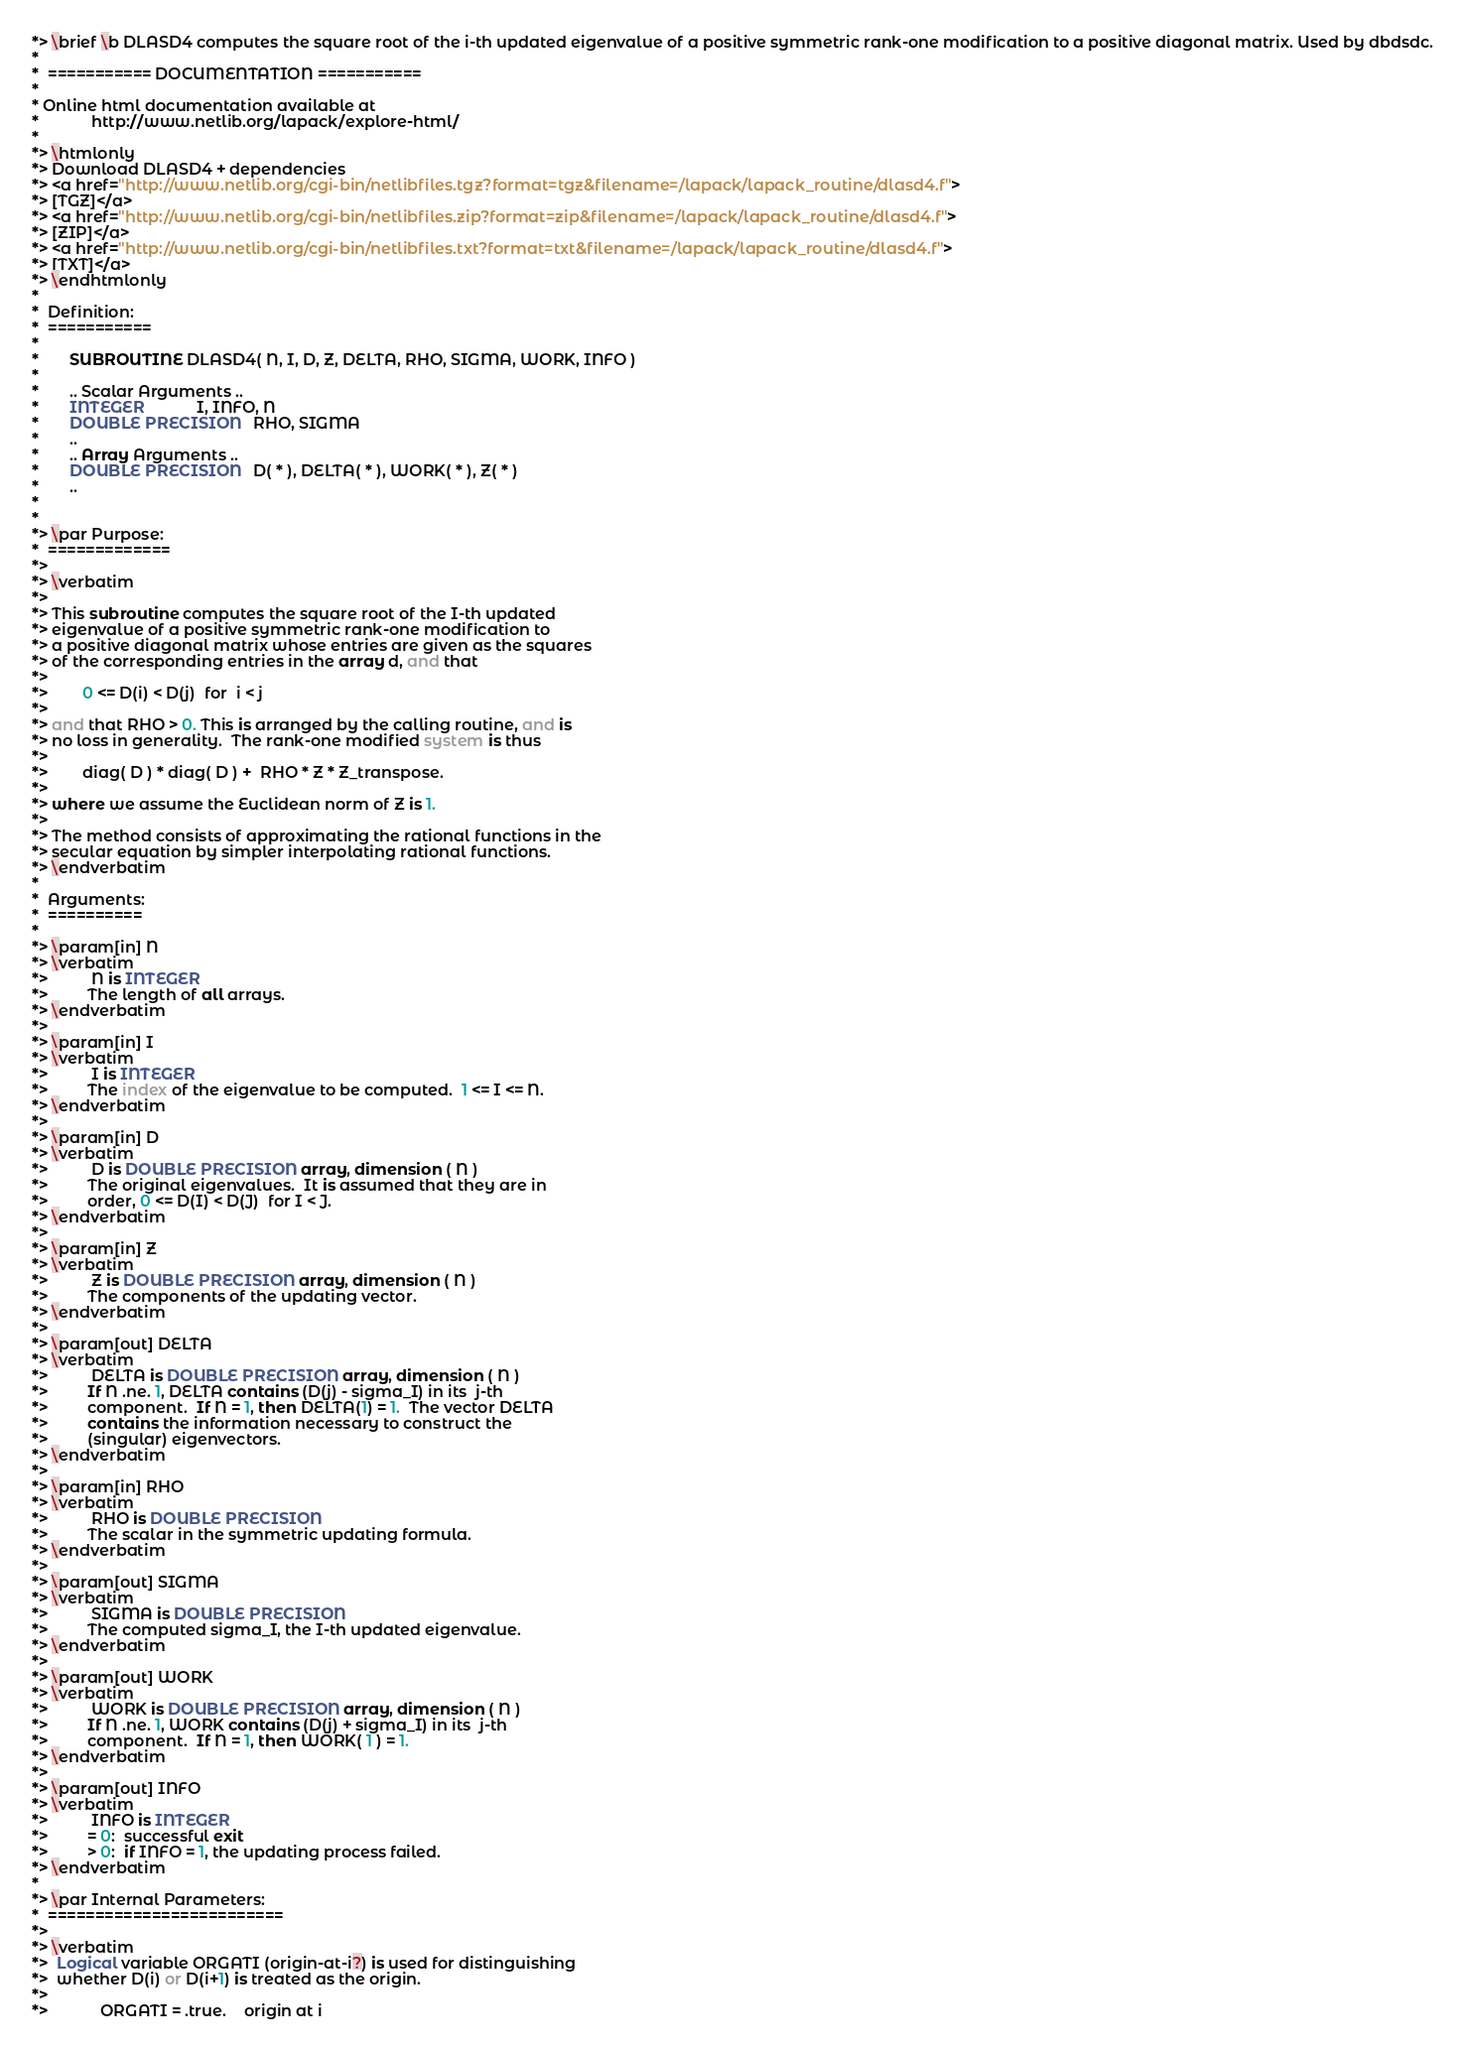Convert code to text. <code><loc_0><loc_0><loc_500><loc_500><_FORTRAN_>*> \brief \b DLASD4 computes the square root of the i-th updated eigenvalue of a positive symmetric rank-one modification to a positive diagonal matrix. Used by dbdsdc.
*
*  =========== DOCUMENTATION ===========
*
* Online html documentation available at
*            http://www.netlib.org/lapack/explore-html/
*
*> \htmlonly
*> Download DLASD4 + dependencies
*> <a href="http://www.netlib.org/cgi-bin/netlibfiles.tgz?format=tgz&filename=/lapack/lapack_routine/dlasd4.f">
*> [TGZ]</a>
*> <a href="http://www.netlib.org/cgi-bin/netlibfiles.zip?format=zip&filename=/lapack/lapack_routine/dlasd4.f">
*> [ZIP]</a>
*> <a href="http://www.netlib.org/cgi-bin/netlibfiles.txt?format=txt&filename=/lapack/lapack_routine/dlasd4.f">
*> [TXT]</a>
*> \endhtmlonly
*
*  Definition:
*  ===========
*
*       SUBROUTINE DLASD4( N, I, D, Z, DELTA, RHO, SIGMA, WORK, INFO )
*
*       .. Scalar Arguments ..
*       INTEGER            I, INFO, N
*       DOUBLE PRECISION   RHO, SIGMA
*       ..
*       .. Array Arguments ..
*       DOUBLE PRECISION   D( * ), DELTA( * ), WORK( * ), Z( * )
*       ..
*
*
*> \par Purpose:
*  =============
*>
*> \verbatim
*>
*> This subroutine computes the square root of the I-th updated
*> eigenvalue of a positive symmetric rank-one modification to
*> a positive diagonal matrix whose entries are given as the squares
*> of the corresponding entries in the array d, and that
*>
*>        0 <= D(i) < D(j)  for  i < j
*>
*> and that RHO > 0. This is arranged by the calling routine, and is
*> no loss in generality.  The rank-one modified system is thus
*>
*>        diag( D ) * diag( D ) +  RHO * Z * Z_transpose.
*>
*> where we assume the Euclidean norm of Z is 1.
*>
*> The method consists of approximating the rational functions in the
*> secular equation by simpler interpolating rational functions.
*> \endverbatim
*
*  Arguments:
*  ==========
*
*> \param[in] N
*> \verbatim
*>          N is INTEGER
*>         The length of all arrays.
*> \endverbatim
*>
*> \param[in] I
*> \verbatim
*>          I is INTEGER
*>         The index of the eigenvalue to be computed.  1 <= I <= N.
*> \endverbatim
*>
*> \param[in] D
*> \verbatim
*>          D is DOUBLE PRECISION array, dimension ( N )
*>         The original eigenvalues.  It is assumed that they are in
*>         order, 0 <= D(I) < D(J)  for I < J.
*> \endverbatim
*>
*> \param[in] Z
*> \verbatim
*>          Z is DOUBLE PRECISION array, dimension ( N )
*>         The components of the updating vector.
*> \endverbatim
*>
*> \param[out] DELTA
*> \verbatim
*>          DELTA is DOUBLE PRECISION array, dimension ( N )
*>         If N .ne. 1, DELTA contains (D(j) - sigma_I) in its  j-th
*>         component.  If N = 1, then DELTA(1) = 1.  The vector DELTA
*>         contains the information necessary to construct the
*>         (singular) eigenvectors.
*> \endverbatim
*>
*> \param[in] RHO
*> \verbatim
*>          RHO is DOUBLE PRECISION
*>         The scalar in the symmetric updating formula.
*> \endverbatim
*>
*> \param[out] SIGMA
*> \verbatim
*>          SIGMA is DOUBLE PRECISION
*>         The computed sigma_I, the I-th updated eigenvalue.
*> \endverbatim
*>
*> \param[out] WORK
*> \verbatim
*>          WORK is DOUBLE PRECISION array, dimension ( N )
*>         If N .ne. 1, WORK contains (D(j) + sigma_I) in its  j-th
*>         component.  If N = 1, then WORK( 1 ) = 1.
*> \endverbatim
*>
*> \param[out] INFO
*> \verbatim
*>          INFO is INTEGER
*>         = 0:  successful exit
*>         > 0:  if INFO = 1, the updating process failed.
*> \endverbatim
*
*> \par Internal Parameters:
*  =========================
*>
*> \verbatim
*>  Logical variable ORGATI (origin-at-i?) is used for distinguishing
*>  whether D(i) or D(i+1) is treated as the origin.
*>
*>            ORGATI = .true.    origin at i</code> 